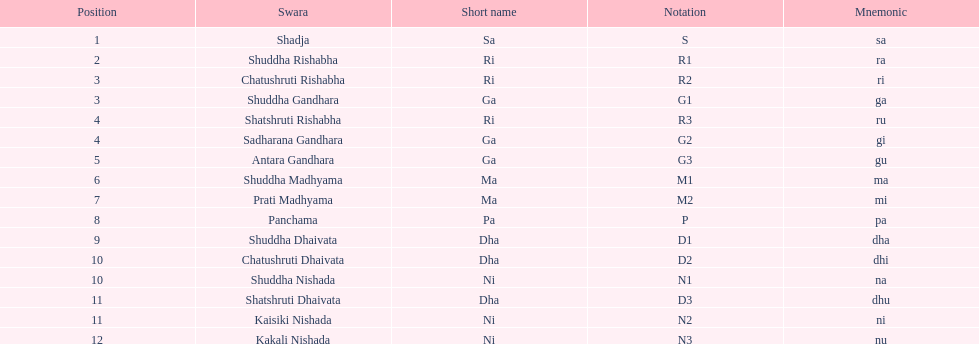Find the 9th position swara. what is its short name? Dha. 